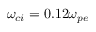Convert formula to latex. <formula><loc_0><loc_0><loc_500><loc_500>\omega _ { c i } = 0 . 1 2 \omega _ { p e }</formula> 